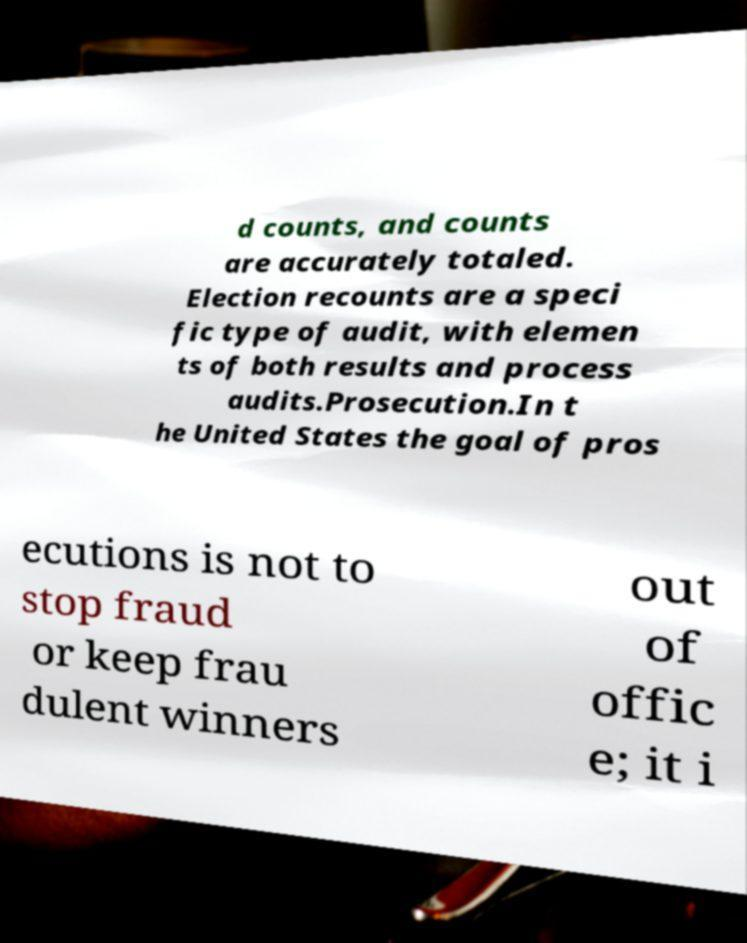For documentation purposes, I need the text within this image transcribed. Could you provide that? d counts, and counts are accurately totaled. Election recounts are a speci fic type of audit, with elemen ts of both results and process audits.Prosecution.In t he United States the goal of pros ecutions is not to stop fraud or keep frau dulent winners out of offic e; it i 